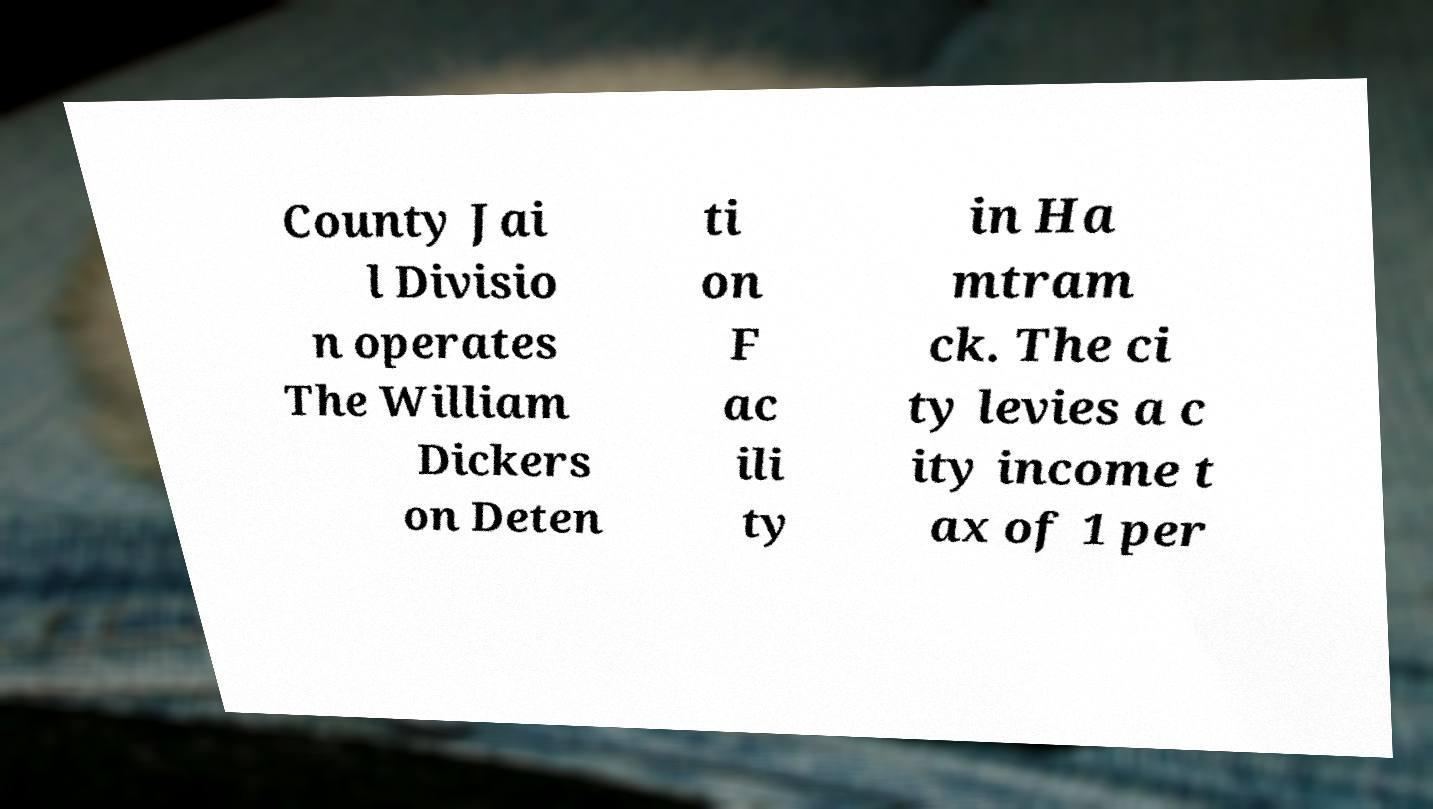Could you assist in decoding the text presented in this image and type it out clearly? County Jai l Divisio n operates The William Dickers on Deten ti on F ac ili ty in Ha mtram ck. The ci ty levies a c ity income t ax of 1 per 